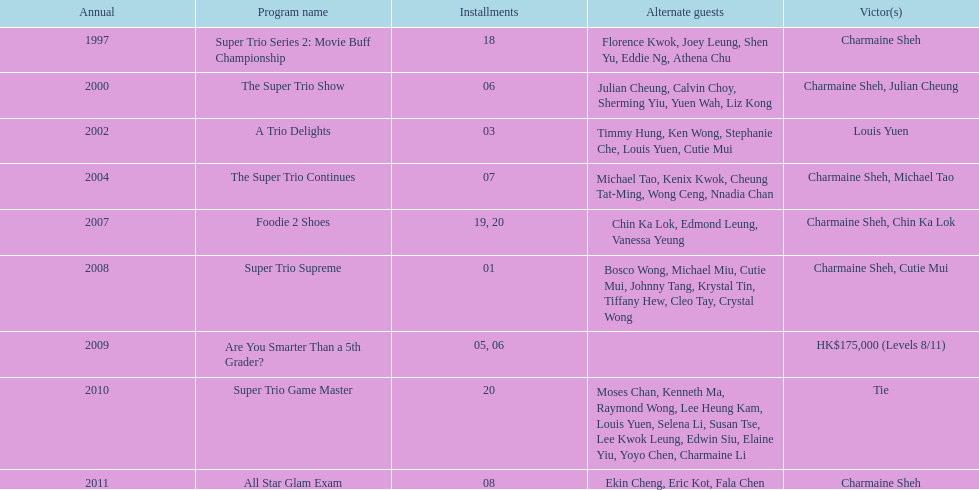What was the total number of trio series shows were charmaine sheh on? 6. 